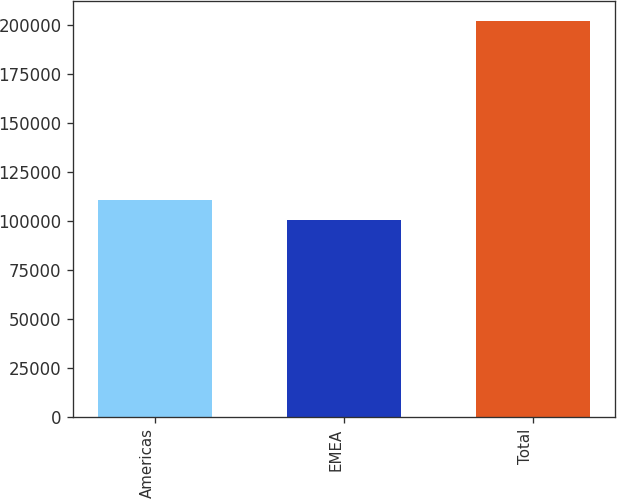<chart> <loc_0><loc_0><loc_500><loc_500><bar_chart><fcel>Americas<fcel>EMEA<fcel>Total<nl><fcel>110627<fcel>100453<fcel>202191<nl></chart> 